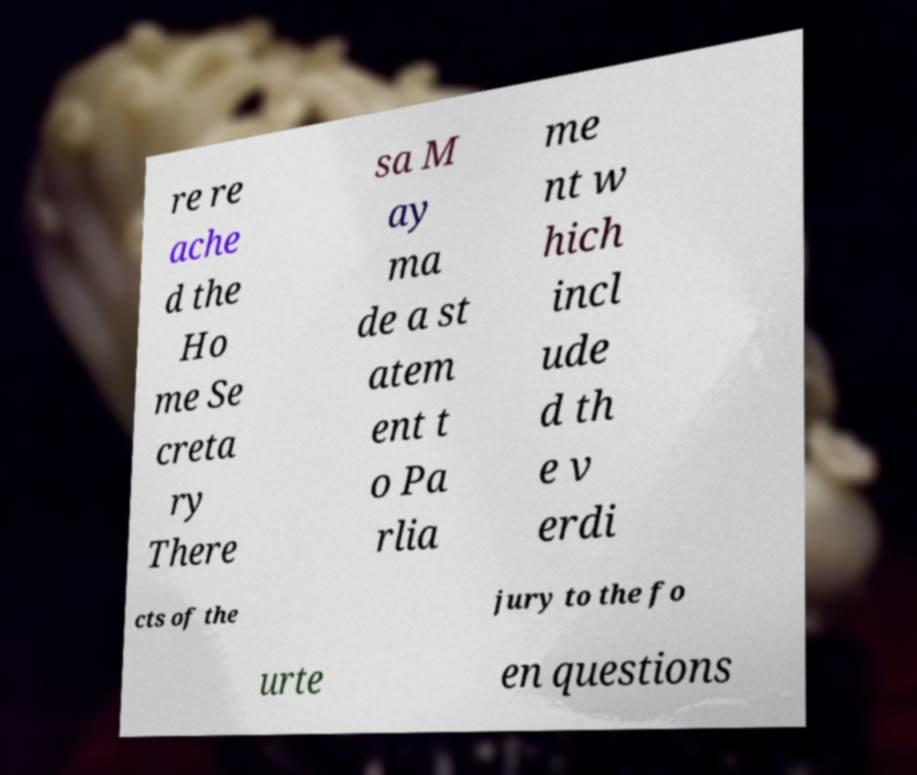I need the written content from this picture converted into text. Can you do that? re re ache d the Ho me Se creta ry There sa M ay ma de a st atem ent t o Pa rlia me nt w hich incl ude d th e v erdi cts of the jury to the fo urte en questions 